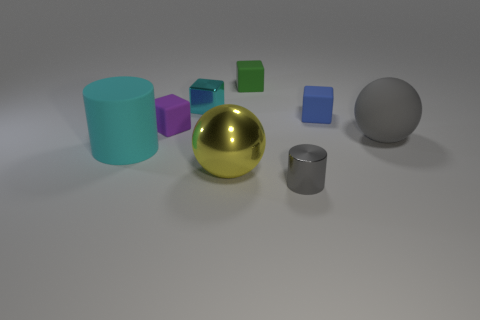Add 2 large gray things. How many objects exist? 10 Subtract all tiny rubber blocks. How many blocks are left? 1 Subtract all cyan blocks. How many blocks are left? 3 Subtract all yellow spheres. How many purple cubes are left? 1 Subtract all cyan rubber blocks. Subtract all purple things. How many objects are left? 7 Add 1 gray spheres. How many gray spheres are left? 2 Add 4 metal things. How many metal things exist? 7 Subtract 0 cyan balls. How many objects are left? 8 Subtract all balls. How many objects are left? 6 Subtract 2 cylinders. How many cylinders are left? 0 